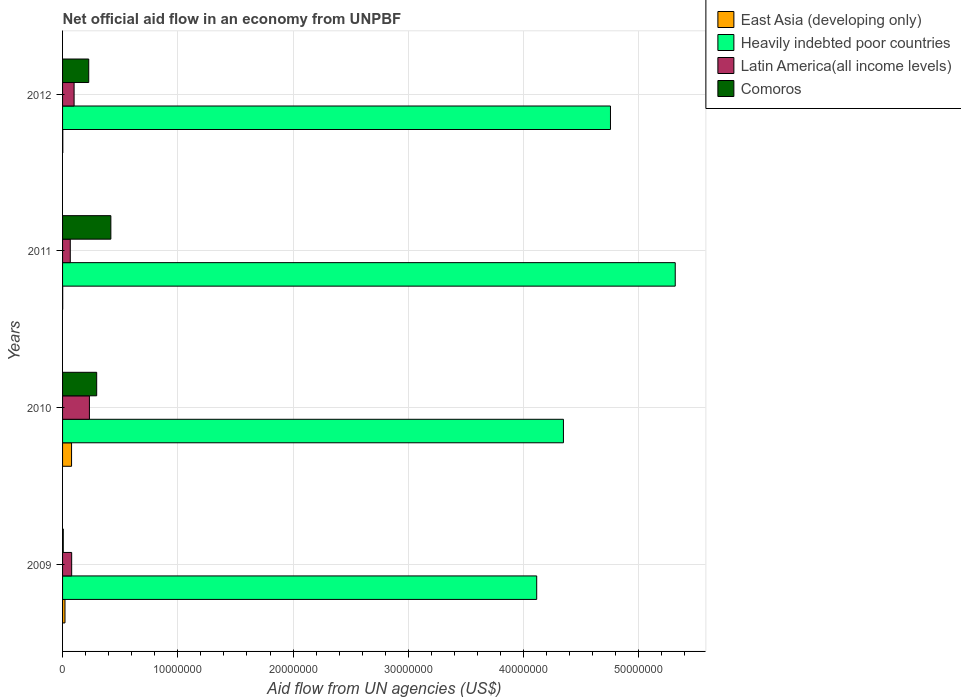How many different coloured bars are there?
Your answer should be very brief. 4. How many groups of bars are there?
Make the answer very short. 4. Are the number of bars per tick equal to the number of legend labels?
Your answer should be compact. Yes. Are the number of bars on each tick of the Y-axis equal?
Give a very brief answer. Yes. How many bars are there on the 2nd tick from the top?
Offer a terse response. 4. What is the label of the 1st group of bars from the top?
Offer a very short reply. 2012. In how many cases, is the number of bars for a given year not equal to the number of legend labels?
Ensure brevity in your answer.  0. What is the net official aid flow in East Asia (developing only) in 2012?
Give a very brief answer. 2.00e+04. Across all years, what is the maximum net official aid flow in East Asia (developing only)?
Ensure brevity in your answer.  7.80e+05. Across all years, what is the minimum net official aid flow in Heavily indebted poor countries?
Your answer should be very brief. 4.11e+07. In which year was the net official aid flow in Comoros maximum?
Keep it short and to the point. 2011. What is the total net official aid flow in Latin America(all income levels) in the graph?
Provide a succinct answer. 4.79e+06. What is the difference between the net official aid flow in Heavily indebted poor countries in 2009 and that in 2012?
Offer a very short reply. -6.40e+06. What is the difference between the net official aid flow in Comoros in 2011 and the net official aid flow in Heavily indebted poor countries in 2012?
Offer a very short reply. -4.34e+07. What is the average net official aid flow in Latin America(all income levels) per year?
Ensure brevity in your answer.  1.20e+06. In the year 2010, what is the difference between the net official aid flow in East Asia (developing only) and net official aid flow in Latin America(all income levels)?
Your answer should be very brief. -1.55e+06. What is the ratio of the net official aid flow in Latin America(all income levels) in 2009 to that in 2012?
Your answer should be very brief. 0.79. Is the difference between the net official aid flow in East Asia (developing only) in 2009 and 2011 greater than the difference between the net official aid flow in Latin America(all income levels) in 2009 and 2011?
Ensure brevity in your answer.  Yes. What is the difference between the highest and the second highest net official aid flow in East Asia (developing only)?
Your answer should be very brief. 5.70e+05. What is the difference between the highest and the lowest net official aid flow in Heavily indebted poor countries?
Give a very brief answer. 1.20e+07. What does the 3rd bar from the top in 2010 represents?
Provide a short and direct response. Heavily indebted poor countries. What does the 2nd bar from the bottom in 2010 represents?
Provide a succinct answer. Heavily indebted poor countries. How many bars are there?
Your answer should be compact. 16. How many years are there in the graph?
Provide a short and direct response. 4. Where does the legend appear in the graph?
Your response must be concise. Top right. How many legend labels are there?
Offer a terse response. 4. What is the title of the graph?
Make the answer very short. Net official aid flow in an economy from UNPBF. Does "Senegal" appear as one of the legend labels in the graph?
Keep it short and to the point. No. What is the label or title of the X-axis?
Offer a very short reply. Aid flow from UN agencies (US$). What is the Aid flow from UN agencies (US$) of East Asia (developing only) in 2009?
Offer a terse response. 2.10e+05. What is the Aid flow from UN agencies (US$) in Heavily indebted poor countries in 2009?
Your answer should be very brief. 4.11e+07. What is the Aid flow from UN agencies (US$) of Latin America(all income levels) in 2009?
Your answer should be very brief. 7.90e+05. What is the Aid flow from UN agencies (US$) of Comoros in 2009?
Your response must be concise. 6.00e+04. What is the Aid flow from UN agencies (US$) of East Asia (developing only) in 2010?
Give a very brief answer. 7.80e+05. What is the Aid flow from UN agencies (US$) in Heavily indebted poor countries in 2010?
Offer a terse response. 4.35e+07. What is the Aid flow from UN agencies (US$) of Latin America(all income levels) in 2010?
Offer a very short reply. 2.33e+06. What is the Aid flow from UN agencies (US$) of Comoros in 2010?
Ensure brevity in your answer.  2.96e+06. What is the Aid flow from UN agencies (US$) in East Asia (developing only) in 2011?
Make the answer very short. 10000. What is the Aid flow from UN agencies (US$) of Heavily indebted poor countries in 2011?
Your response must be concise. 5.32e+07. What is the Aid flow from UN agencies (US$) in Latin America(all income levels) in 2011?
Offer a very short reply. 6.70e+05. What is the Aid flow from UN agencies (US$) in Comoros in 2011?
Your answer should be very brief. 4.19e+06. What is the Aid flow from UN agencies (US$) in Heavily indebted poor countries in 2012?
Keep it short and to the point. 4.75e+07. What is the Aid flow from UN agencies (US$) in Comoros in 2012?
Offer a very short reply. 2.27e+06. Across all years, what is the maximum Aid flow from UN agencies (US$) of East Asia (developing only)?
Give a very brief answer. 7.80e+05. Across all years, what is the maximum Aid flow from UN agencies (US$) in Heavily indebted poor countries?
Your response must be concise. 5.32e+07. Across all years, what is the maximum Aid flow from UN agencies (US$) in Latin America(all income levels)?
Provide a succinct answer. 2.33e+06. Across all years, what is the maximum Aid flow from UN agencies (US$) in Comoros?
Your answer should be compact. 4.19e+06. Across all years, what is the minimum Aid flow from UN agencies (US$) of Heavily indebted poor countries?
Provide a short and direct response. 4.11e+07. Across all years, what is the minimum Aid flow from UN agencies (US$) in Latin America(all income levels)?
Give a very brief answer. 6.70e+05. Across all years, what is the minimum Aid flow from UN agencies (US$) in Comoros?
Your answer should be very brief. 6.00e+04. What is the total Aid flow from UN agencies (US$) of East Asia (developing only) in the graph?
Ensure brevity in your answer.  1.02e+06. What is the total Aid flow from UN agencies (US$) of Heavily indebted poor countries in the graph?
Your answer should be very brief. 1.85e+08. What is the total Aid flow from UN agencies (US$) of Latin America(all income levels) in the graph?
Offer a very short reply. 4.79e+06. What is the total Aid flow from UN agencies (US$) of Comoros in the graph?
Ensure brevity in your answer.  9.48e+06. What is the difference between the Aid flow from UN agencies (US$) in East Asia (developing only) in 2009 and that in 2010?
Your answer should be compact. -5.70e+05. What is the difference between the Aid flow from UN agencies (US$) of Heavily indebted poor countries in 2009 and that in 2010?
Offer a terse response. -2.32e+06. What is the difference between the Aid flow from UN agencies (US$) of Latin America(all income levels) in 2009 and that in 2010?
Provide a short and direct response. -1.54e+06. What is the difference between the Aid flow from UN agencies (US$) in Comoros in 2009 and that in 2010?
Your answer should be compact. -2.90e+06. What is the difference between the Aid flow from UN agencies (US$) in Heavily indebted poor countries in 2009 and that in 2011?
Keep it short and to the point. -1.20e+07. What is the difference between the Aid flow from UN agencies (US$) of Latin America(all income levels) in 2009 and that in 2011?
Give a very brief answer. 1.20e+05. What is the difference between the Aid flow from UN agencies (US$) of Comoros in 2009 and that in 2011?
Provide a succinct answer. -4.13e+06. What is the difference between the Aid flow from UN agencies (US$) in East Asia (developing only) in 2009 and that in 2012?
Provide a short and direct response. 1.90e+05. What is the difference between the Aid flow from UN agencies (US$) in Heavily indebted poor countries in 2009 and that in 2012?
Keep it short and to the point. -6.40e+06. What is the difference between the Aid flow from UN agencies (US$) in Comoros in 2009 and that in 2012?
Provide a short and direct response. -2.21e+06. What is the difference between the Aid flow from UN agencies (US$) of East Asia (developing only) in 2010 and that in 2011?
Your answer should be compact. 7.70e+05. What is the difference between the Aid flow from UN agencies (US$) in Heavily indebted poor countries in 2010 and that in 2011?
Keep it short and to the point. -9.70e+06. What is the difference between the Aid flow from UN agencies (US$) of Latin America(all income levels) in 2010 and that in 2011?
Give a very brief answer. 1.66e+06. What is the difference between the Aid flow from UN agencies (US$) in Comoros in 2010 and that in 2011?
Make the answer very short. -1.23e+06. What is the difference between the Aid flow from UN agencies (US$) in East Asia (developing only) in 2010 and that in 2012?
Your answer should be compact. 7.60e+05. What is the difference between the Aid flow from UN agencies (US$) in Heavily indebted poor countries in 2010 and that in 2012?
Your response must be concise. -4.08e+06. What is the difference between the Aid flow from UN agencies (US$) in Latin America(all income levels) in 2010 and that in 2012?
Ensure brevity in your answer.  1.33e+06. What is the difference between the Aid flow from UN agencies (US$) of Comoros in 2010 and that in 2012?
Offer a terse response. 6.90e+05. What is the difference between the Aid flow from UN agencies (US$) in Heavily indebted poor countries in 2011 and that in 2012?
Provide a succinct answer. 5.62e+06. What is the difference between the Aid flow from UN agencies (US$) in Latin America(all income levels) in 2011 and that in 2012?
Offer a very short reply. -3.30e+05. What is the difference between the Aid flow from UN agencies (US$) of Comoros in 2011 and that in 2012?
Offer a terse response. 1.92e+06. What is the difference between the Aid flow from UN agencies (US$) of East Asia (developing only) in 2009 and the Aid flow from UN agencies (US$) of Heavily indebted poor countries in 2010?
Offer a very short reply. -4.32e+07. What is the difference between the Aid flow from UN agencies (US$) of East Asia (developing only) in 2009 and the Aid flow from UN agencies (US$) of Latin America(all income levels) in 2010?
Your answer should be very brief. -2.12e+06. What is the difference between the Aid flow from UN agencies (US$) in East Asia (developing only) in 2009 and the Aid flow from UN agencies (US$) in Comoros in 2010?
Keep it short and to the point. -2.75e+06. What is the difference between the Aid flow from UN agencies (US$) in Heavily indebted poor countries in 2009 and the Aid flow from UN agencies (US$) in Latin America(all income levels) in 2010?
Your answer should be compact. 3.88e+07. What is the difference between the Aid flow from UN agencies (US$) of Heavily indebted poor countries in 2009 and the Aid flow from UN agencies (US$) of Comoros in 2010?
Offer a terse response. 3.82e+07. What is the difference between the Aid flow from UN agencies (US$) of Latin America(all income levels) in 2009 and the Aid flow from UN agencies (US$) of Comoros in 2010?
Ensure brevity in your answer.  -2.17e+06. What is the difference between the Aid flow from UN agencies (US$) of East Asia (developing only) in 2009 and the Aid flow from UN agencies (US$) of Heavily indebted poor countries in 2011?
Offer a very short reply. -5.30e+07. What is the difference between the Aid flow from UN agencies (US$) of East Asia (developing only) in 2009 and the Aid flow from UN agencies (US$) of Latin America(all income levels) in 2011?
Make the answer very short. -4.60e+05. What is the difference between the Aid flow from UN agencies (US$) of East Asia (developing only) in 2009 and the Aid flow from UN agencies (US$) of Comoros in 2011?
Provide a short and direct response. -3.98e+06. What is the difference between the Aid flow from UN agencies (US$) of Heavily indebted poor countries in 2009 and the Aid flow from UN agencies (US$) of Latin America(all income levels) in 2011?
Give a very brief answer. 4.05e+07. What is the difference between the Aid flow from UN agencies (US$) in Heavily indebted poor countries in 2009 and the Aid flow from UN agencies (US$) in Comoros in 2011?
Make the answer very short. 3.70e+07. What is the difference between the Aid flow from UN agencies (US$) of Latin America(all income levels) in 2009 and the Aid flow from UN agencies (US$) of Comoros in 2011?
Give a very brief answer. -3.40e+06. What is the difference between the Aid flow from UN agencies (US$) in East Asia (developing only) in 2009 and the Aid flow from UN agencies (US$) in Heavily indebted poor countries in 2012?
Keep it short and to the point. -4.73e+07. What is the difference between the Aid flow from UN agencies (US$) in East Asia (developing only) in 2009 and the Aid flow from UN agencies (US$) in Latin America(all income levels) in 2012?
Your answer should be compact. -7.90e+05. What is the difference between the Aid flow from UN agencies (US$) of East Asia (developing only) in 2009 and the Aid flow from UN agencies (US$) of Comoros in 2012?
Give a very brief answer. -2.06e+06. What is the difference between the Aid flow from UN agencies (US$) of Heavily indebted poor countries in 2009 and the Aid flow from UN agencies (US$) of Latin America(all income levels) in 2012?
Offer a very short reply. 4.01e+07. What is the difference between the Aid flow from UN agencies (US$) in Heavily indebted poor countries in 2009 and the Aid flow from UN agencies (US$) in Comoros in 2012?
Your answer should be compact. 3.89e+07. What is the difference between the Aid flow from UN agencies (US$) of Latin America(all income levels) in 2009 and the Aid flow from UN agencies (US$) of Comoros in 2012?
Your answer should be compact. -1.48e+06. What is the difference between the Aid flow from UN agencies (US$) of East Asia (developing only) in 2010 and the Aid flow from UN agencies (US$) of Heavily indebted poor countries in 2011?
Keep it short and to the point. -5.24e+07. What is the difference between the Aid flow from UN agencies (US$) in East Asia (developing only) in 2010 and the Aid flow from UN agencies (US$) in Latin America(all income levels) in 2011?
Make the answer very short. 1.10e+05. What is the difference between the Aid flow from UN agencies (US$) in East Asia (developing only) in 2010 and the Aid flow from UN agencies (US$) in Comoros in 2011?
Your answer should be very brief. -3.41e+06. What is the difference between the Aid flow from UN agencies (US$) in Heavily indebted poor countries in 2010 and the Aid flow from UN agencies (US$) in Latin America(all income levels) in 2011?
Provide a short and direct response. 4.28e+07. What is the difference between the Aid flow from UN agencies (US$) of Heavily indebted poor countries in 2010 and the Aid flow from UN agencies (US$) of Comoros in 2011?
Make the answer very short. 3.93e+07. What is the difference between the Aid flow from UN agencies (US$) of Latin America(all income levels) in 2010 and the Aid flow from UN agencies (US$) of Comoros in 2011?
Offer a terse response. -1.86e+06. What is the difference between the Aid flow from UN agencies (US$) in East Asia (developing only) in 2010 and the Aid flow from UN agencies (US$) in Heavily indebted poor countries in 2012?
Ensure brevity in your answer.  -4.68e+07. What is the difference between the Aid flow from UN agencies (US$) in East Asia (developing only) in 2010 and the Aid flow from UN agencies (US$) in Comoros in 2012?
Keep it short and to the point. -1.49e+06. What is the difference between the Aid flow from UN agencies (US$) of Heavily indebted poor countries in 2010 and the Aid flow from UN agencies (US$) of Latin America(all income levels) in 2012?
Your answer should be compact. 4.25e+07. What is the difference between the Aid flow from UN agencies (US$) of Heavily indebted poor countries in 2010 and the Aid flow from UN agencies (US$) of Comoros in 2012?
Offer a very short reply. 4.12e+07. What is the difference between the Aid flow from UN agencies (US$) of Latin America(all income levels) in 2010 and the Aid flow from UN agencies (US$) of Comoros in 2012?
Ensure brevity in your answer.  6.00e+04. What is the difference between the Aid flow from UN agencies (US$) of East Asia (developing only) in 2011 and the Aid flow from UN agencies (US$) of Heavily indebted poor countries in 2012?
Make the answer very short. -4.75e+07. What is the difference between the Aid flow from UN agencies (US$) in East Asia (developing only) in 2011 and the Aid flow from UN agencies (US$) in Latin America(all income levels) in 2012?
Make the answer very short. -9.90e+05. What is the difference between the Aid flow from UN agencies (US$) of East Asia (developing only) in 2011 and the Aid flow from UN agencies (US$) of Comoros in 2012?
Provide a short and direct response. -2.26e+06. What is the difference between the Aid flow from UN agencies (US$) of Heavily indebted poor countries in 2011 and the Aid flow from UN agencies (US$) of Latin America(all income levels) in 2012?
Give a very brief answer. 5.22e+07. What is the difference between the Aid flow from UN agencies (US$) in Heavily indebted poor countries in 2011 and the Aid flow from UN agencies (US$) in Comoros in 2012?
Your answer should be very brief. 5.09e+07. What is the difference between the Aid flow from UN agencies (US$) of Latin America(all income levels) in 2011 and the Aid flow from UN agencies (US$) of Comoros in 2012?
Your answer should be compact. -1.60e+06. What is the average Aid flow from UN agencies (US$) in East Asia (developing only) per year?
Offer a very short reply. 2.55e+05. What is the average Aid flow from UN agencies (US$) in Heavily indebted poor countries per year?
Ensure brevity in your answer.  4.63e+07. What is the average Aid flow from UN agencies (US$) of Latin America(all income levels) per year?
Provide a short and direct response. 1.20e+06. What is the average Aid flow from UN agencies (US$) of Comoros per year?
Keep it short and to the point. 2.37e+06. In the year 2009, what is the difference between the Aid flow from UN agencies (US$) in East Asia (developing only) and Aid flow from UN agencies (US$) in Heavily indebted poor countries?
Your answer should be compact. -4.09e+07. In the year 2009, what is the difference between the Aid flow from UN agencies (US$) of East Asia (developing only) and Aid flow from UN agencies (US$) of Latin America(all income levels)?
Provide a short and direct response. -5.80e+05. In the year 2009, what is the difference between the Aid flow from UN agencies (US$) of Heavily indebted poor countries and Aid flow from UN agencies (US$) of Latin America(all income levels)?
Keep it short and to the point. 4.04e+07. In the year 2009, what is the difference between the Aid flow from UN agencies (US$) of Heavily indebted poor countries and Aid flow from UN agencies (US$) of Comoros?
Make the answer very short. 4.11e+07. In the year 2009, what is the difference between the Aid flow from UN agencies (US$) in Latin America(all income levels) and Aid flow from UN agencies (US$) in Comoros?
Ensure brevity in your answer.  7.30e+05. In the year 2010, what is the difference between the Aid flow from UN agencies (US$) of East Asia (developing only) and Aid flow from UN agencies (US$) of Heavily indebted poor countries?
Offer a very short reply. -4.27e+07. In the year 2010, what is the difference between the Aid flow from UN agencies (US$) of East Asia (developing only) and Aid flow from UN agencies (US$) of Latin America(all income levels)?
Offer a very short reply. -1.55e+06. In the year 2010, what is the difference between the Aid flow from UN agencies (US$) in East Asia (developing only) and Aid flow from UN agencies (US$) in Comoros?
Offer a very short reply. -2.18e+06. In the year 2010, what is the difference between the Aid flow from UN agencies (US$) of Heavily indebted poor countries and Aid flow from UN agencies (US$) of Latin America(all income levels)?
Provide a short and direct response. 4.11e+07. In the year 2010, what is the difference between the Aid flow from UN agencies (US$) of Heavily indebted poor countries and Aid flow from UN agencies (US$) of Comoros?
Ensure brevity in your answer.  4.05e+07. In the year 2010, what is the difference between the Aid flow from UN agencies (US$) in Latin America(all income levels) and Aid flow from UN agencies (US$) in Comoros?
Keep it short and to the point. -6.30e+05. In the year 2011, what is the difference between the Aid flow from UN agencies (US$) of East Asia (developing only) and Aid flow from UN agencies (US$) of Heavily indebted poor countries?
Your answer should be compact. -5.32e+07. In the year 2011, what is the difference between the Aid flow from UN agencies (US$) in East Asia (developing only) and Aid flow from UN agencies (US$) in Latin America(all income levels)?
Your answer should be compact. -6.60e+05. In the year 2011, what is the difference between the Aid flow from UN agencies (US$) of East Asia (developing only) and Aid flow from UN agencies (US$) of Comoros?
Provide a succinct answer. -4.18e+06. In the year 2011, what is the difference between the Aid flow from UN agencies (US$) of Heavily indebted poor countries and Aid flow from UN agencies (US$) of Latin America(all income levels)?
Offer a very short reply. 5.25e+07. In the year 2011, what is the difference between the Aid flow from UN agencies (US$) of Heavily indebted poor countries and Aid flow from UN agencies (US$) of Comoros?
Give a very brief answer. 4.90e+07. In the year 2011, what is the difference between the Aid flow from UN agencies (US$) in Latin America(all income levels) and Aid flow from UN agencies (US$) in Comoros?
Your response must be concise. -3.52e+06. In the year 2012, what is the difference between the Aid flow from UN agencies (US$) of East Asia (developing only) and Aid flow from UN agencies (US$) of Heavily indebted poor countries?
Your answer should be very brief. -4.75e+07. In the year 2012, what is the difference between the Aid flow from UN agencies (US$) in East Asia (developing only) and Aid flow from UN agencies (US$) in Latin America(all income levels)?
Make the answer very short. -9.80e+05. In the year 2012, what is the difference between the Aid flow from UN agencies (US$) in East Asia (developing only) and Aid flow from UN agencies (US$) in Comoros?
Give a very brief answer. -2.25e+06. In the year 2012, what is the difference between the Aid flow from UN agencies (US$) of Heavily indebted poor countries and Aid flow from UN agencies (US$) of Latin America(all income levels)?
Ensure brevity in your answer.  4.65e+07. In the year 2012, what is the difference between the Aid flow from UN agencies (US$) in Heavily indebted poor countries and Aid flow from UN agencies (US$) in Comoros?
Ensure brevity in your answer.  4.53e+07. In the year 2012, what is the difference between the Aid flow from UN agencies (US$) of Latin America(all income levels) and Aid flow from UN agencies (US$) of Comoros?
Your answer should be compact. -1.27e+06. What is the ratio of the Aid flow from UN agencies (US$) of East Asia (developing only) in 2009 to that in 2010?
Keep it short and to the point. 0.27. What is the ratio of the Aid flow from UN agencies (US$) of Heavily indebted poor countries in 2009 to that in 2010?
Your answer should be very brief. 0.95. What is the ratio of the Aid flow from UN agencies (US$) of Latin America(all income levels) in 2009 to that in 2010?
Offer a terse response. 0.34. What is the ratio of the Aid flow from UN agencies (US$) in Comoros in 2009 to that in 2010?
Make the answer very short. 0.02. What is the ratio of the Aid flow from UN agencies (US$) in East Asia (developing only) in 2009 to that in 2011?
Provide a succinct answer. 21. What is the ratio of the Aid flow from UN agencies (US$) of Heavily indebted poor countries in 2009 to that in 2011?
Give a very brief answer. 0.77. What is the ratio of the Aid flow from UN agencies (US$) of Latin America(all income levels) in 2009 to that in 2011?
Offer a terse response. 1.18. What is the ratio of the Aid flow from UN agencies (US$) of Comoros in 2009 to that in 2011?
Your response must be concise. 0.01. What is the ratio of the Aid flow from UN agencies (US$) in East Asia (developing only) in 2009 to that in 2012?
Provide a succinct answer. 10.5. What is the ratio of the Aid flow from UN agencies (US$) in Heavily indebted poor countries in 2009 to that in 2012?
Provide a short and direct response. 0.87. What is the ratio of the Aid flow from UN agencies (US$) in Latin America(all income levels) in 2009 to that in 2012?
Offer a very short reply. 0.79. What is the ratio of the Aid flow from UN agencies (US$) in Comoros in 2009 to that in 2012?
Offer a terse response. 0.03. What is the ratio of the Aid flow from UN agencies (US$) of East Asia (developing only) in 2010 to that in 2011?
Ensure brevity in your answer.  78. What is the ratio of the Aid flow from UN agencies (US$) of Heavily indebted poor countries in 2010 to that in 2011?
Your answer should be compact. 0.82. What is the ratio of the Aid flow from UN agencies (US$) of Latin America(all income levels) in 2010 to that in 2011?
Your response must be concise. 3.48. What is the ratio of the Aid flow from UN agencies (US$) in Comoros in 2010 to that in 2011?
Your answer should be compact. 0.71. What is the ratio of the Aid flow from UN agencies (US$) of Heavily indebted poor countries in 2010 to that in 2012?
Keep it short and to the point. 0.91. What is the ratio of the Aid flow from UN agencies (US$) in Latin America(all income levels) in 2010 to that in 2012?
Offer a very short reply. 2.33. What is the ratio of the Aid flow from UN agencies (US$) of Comoros in 2010 to that in 2012?
Provide a short and direct response. 1.3. What is the ratio of the Aid flow from UN agencies (US$) in Heavily indebted poor countries in 2011 to that in 2012?
Your response must be concise. 1.12. What is the ratio of the Aid flow from UN agencies (US$) of Latin America(all income levels) in 2011 to that in 2012?
Your response must be concise. 0.67. What is the ratio of the Aid flow from UN agencies (US$) in Comoros in 2011 to that in 2012?
Your answer should be very brief. 1.85. What is the difference between the highest and the second highest Aid flow from UN agencies (US$) of East Asia (developing only)?
Offer a very short reply. 5.70e+05. What is the difference between the highest and the second highest Aid flow from UN agencies (US$) in Heavily indebted poor countries?
Provide a succinct answer. 5.62e+06. What is the difference between the highest and the second highest Aid flow from UN agencies (US$) in Latin America(all income levels)?
Give a very brief answer. 1.33e+06. What is the difference between the highest and the second highest Aid flow from UN agencies (US$) in Comoros?
Your answer should be very brief. 1.23e+06. What is the difference between the highest and the lowest Aid flow from UN agencies (US$) of East Asia (developing only)?
Provide a succinct answer. 7.70e+05. What is the difference between the highest and the lowest Aid flow from UN agencies (US$) of Heavily indebted poor countries?
Offer a terse response. 1.20e+07. What is the difference between the highest and the lowest Aid flow from UN agencies (US$) of Latin America(all income levels)?
Ensure brevity in your answer.  1.66e+06. What is the difference between the highest and the lowest Aid flow from UN agencies (US$) in Comoros?
Give a very brief answer. 4.13e+06. 